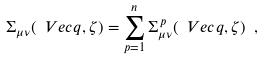<formula> <loc_0><loc_0><loc_500><loc_500>\Sigma _ { \mu \nu } ( \ V e c { q } , \zeta ) = \sum _ { p = 1 } ^ { n } \Sigma ^ { \, p } _ { \mu \nu } ( \ V e c { q } , \zeta ) \ ,</formula> 